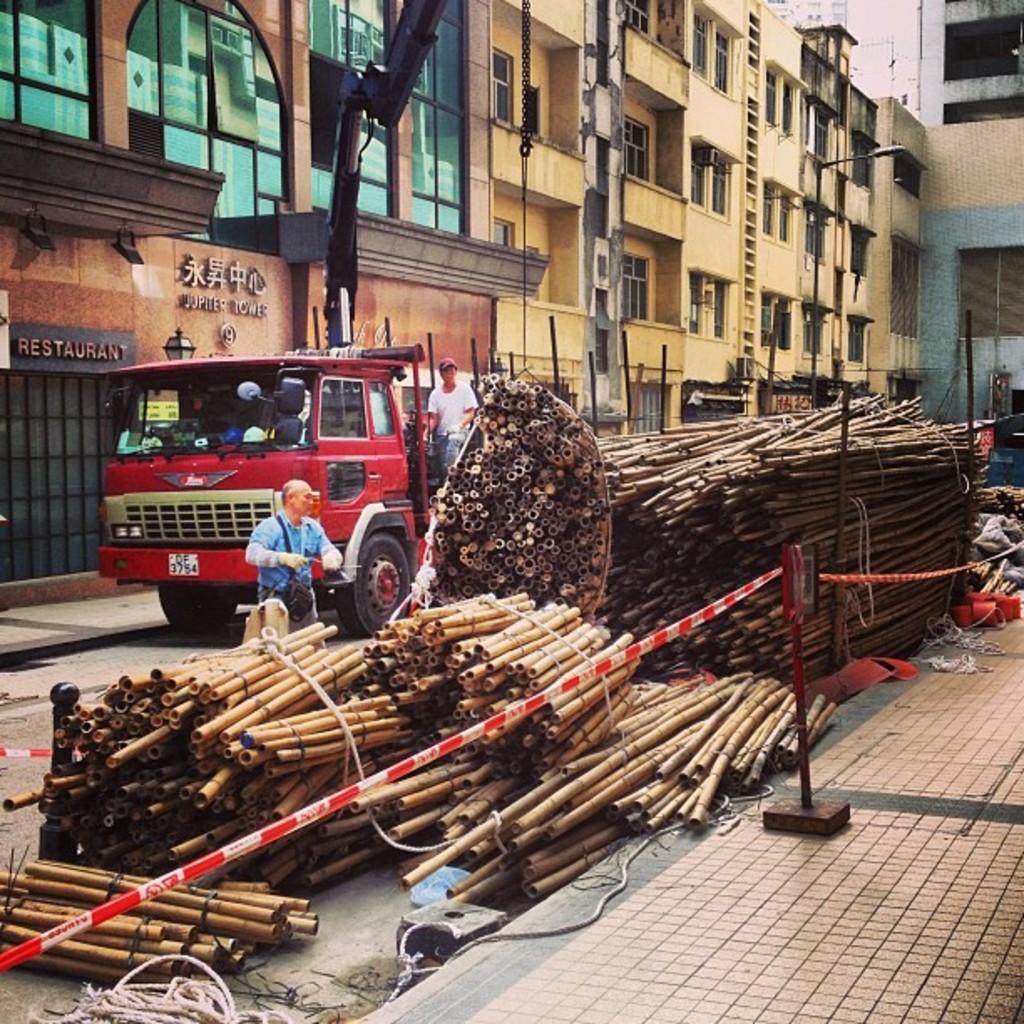In one or two sentences, can you explain what this image depicts? This picture is taken from outside of the building. In this image, on the left side, we can see a building, glass window, we can also see a vehicle which is placed on the road, in the vehicle, we can also see a person sitting. On the left side, we can see a person standing in front of the wood sticks. In the middle of the image, we can see a street light and a cloth, metal rod. In the background, we can see a building, window. At the bottom, we can see some clothes, rope, footpath and a road. 